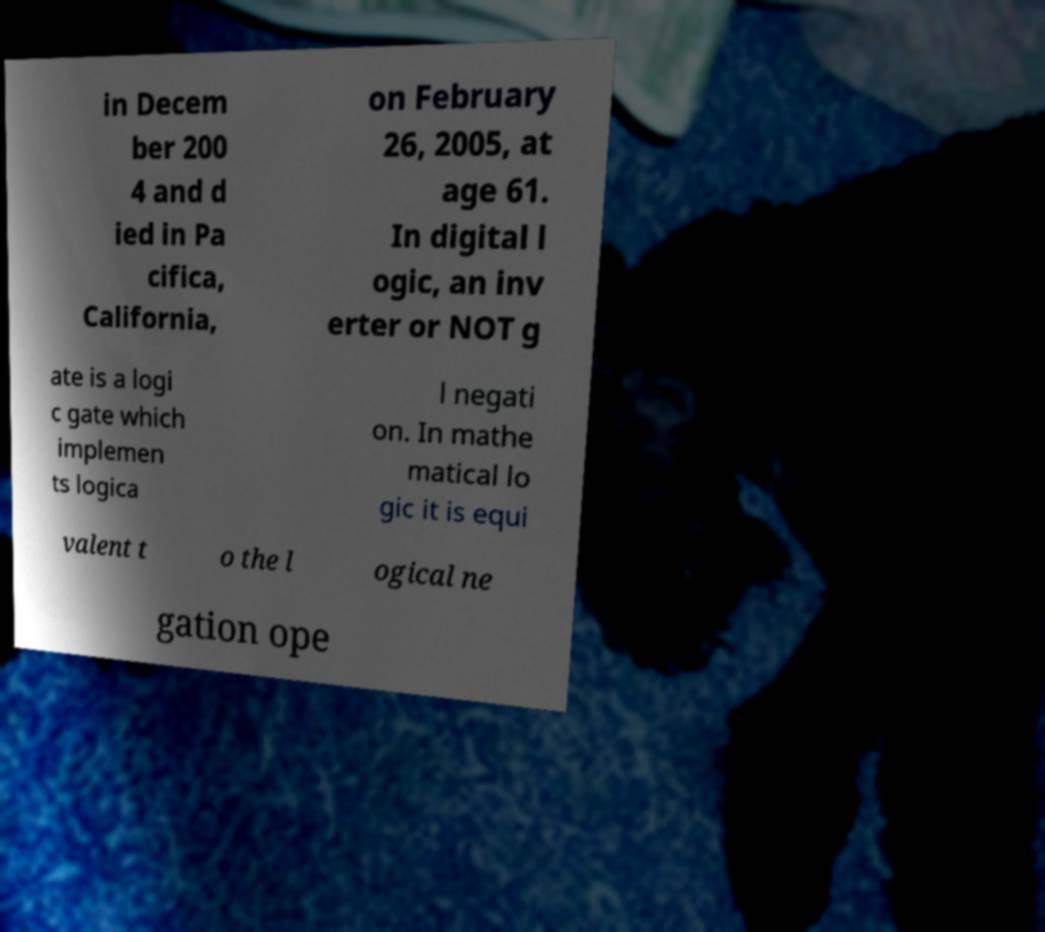What messages or text are displayed in this image? I need them in a readable, typed format. in Decem ber 200 4 and d ied in Pa cifica, California, on February 26, 2005, at age 61. In digital l ogic, an inv erter or NOT g ate is a logi c gate which implemen ts logica l negati on. In mathe matical lo gic it is equi valent t o the l ogical ne gation ope 